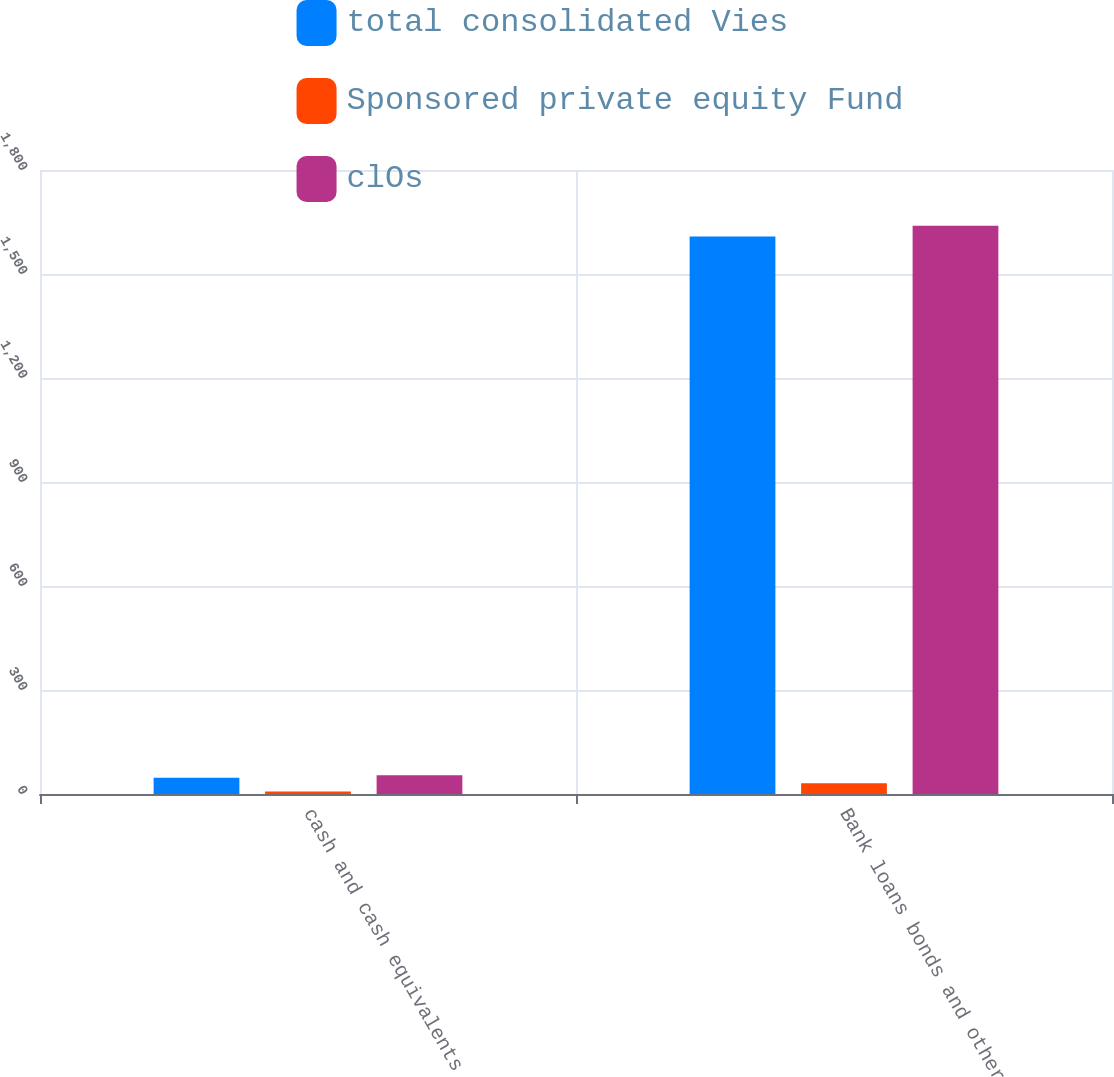Convert chart. <chart><loc_0><loc_0><loc_500><loc_500><stacked_bar_chart><ecel><fcel>cash and cash equivalents<fcel>Bank loans bonds and other<nl><fcel>total consolidated Vies<fcel>47<fcel>1608<nl><fcel>Sponsored private equity Fund<fcel>7<fcel>31<nl><fcel>clOs<fcel>54<fcel>1639<nl></chart> 